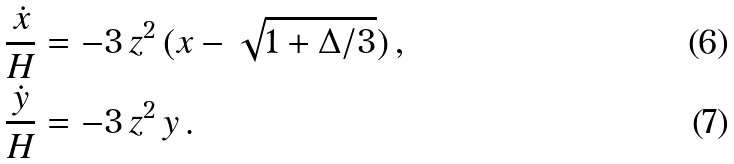<formula> <loc_0><loc_0><loc_500><loc_500>\frac { \dot { x } } { H } & = - 3 \, z ^ { 2 } \, ( x - \sqrt { 1 + \Delta / 3 } ) \, , \\ \frac { \dot { y } } { H } & = - 3 \, z ^ { 2 } \, y \, .</formula> 